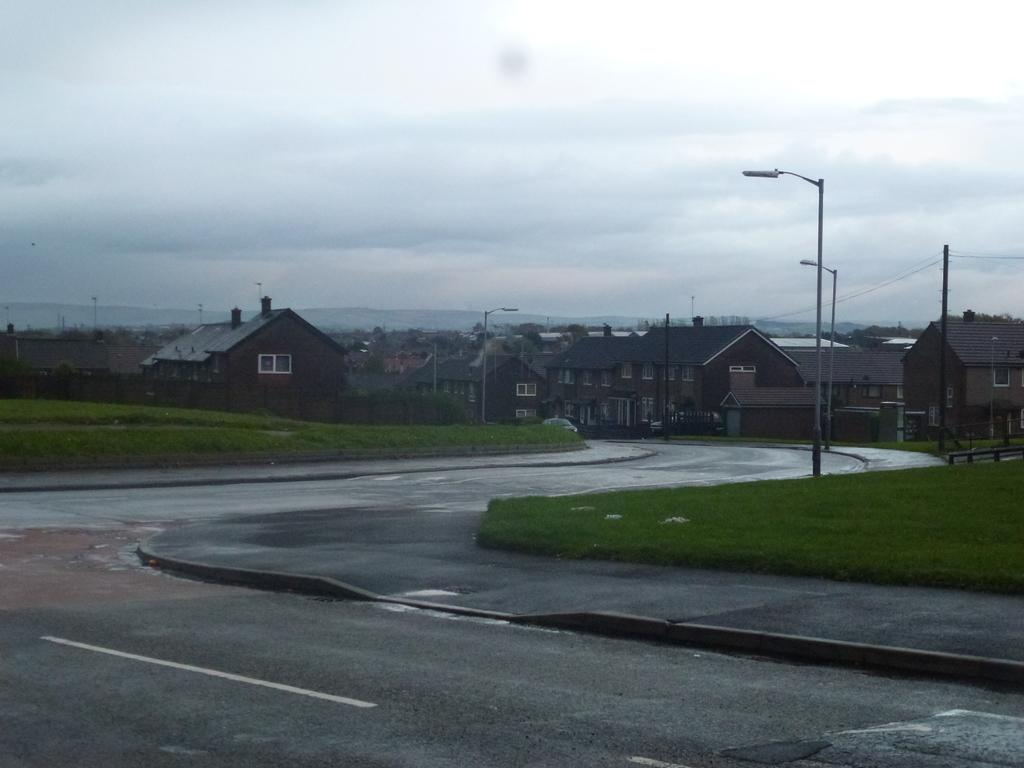What is the main feature of the image? There is a road in the image. What can be seen on both sides of the road? There are poles and grass on both sides of the road. What is visible in the background of the image? There are houses, trees, mountains, clouds, and the sky visible in the background of the image. Where is the mailbox located in the image? There is no mailbox present in the image. Is there a jail visible in the image? There is no jail present in the image. 